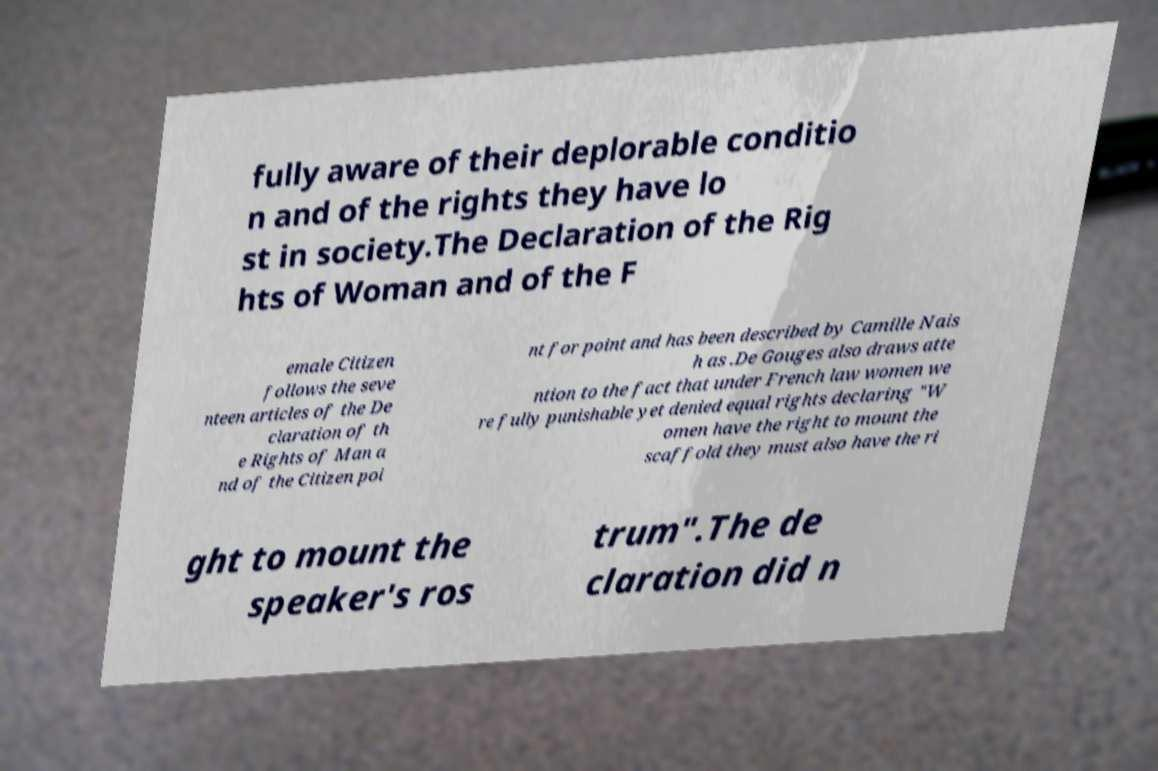Please identify and transcribe the text found in this image. fully aware of their deplorable conditio n and of the rights they have lo st in society.The Declaration of the Rig hts of Woman and of the F emale Citizen follows the seve nteen articles of the De claration of th e Rights of Man a nd of the Citizen poi nt for point and has been described by Camille Nais h as .De Gouges also draws atte ntion to the fact that under French law women we re fully punishable yet denied equal rights declaring "W omen have the right to mount the scaffold they must also have the ri ght to mount the speaker's ros trum".The de claration did n 